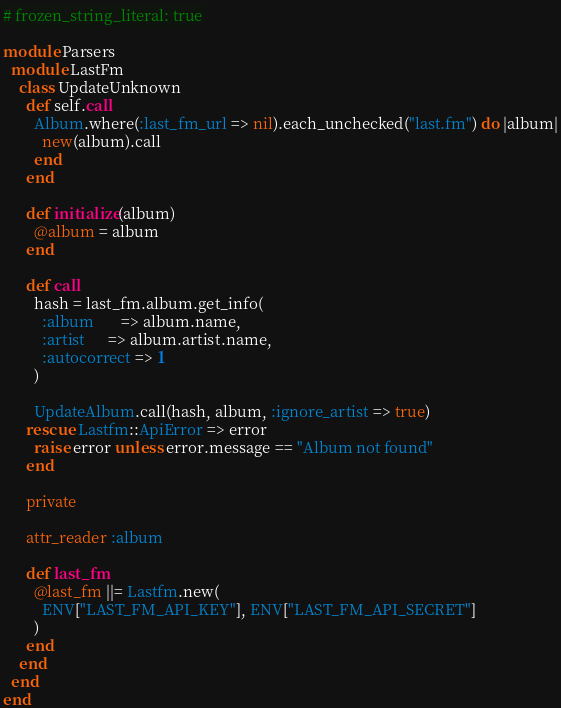Convert code to text. <code><loc_0><loc_0><loc_500><loc_500><_Ruby_># frozen_string_literal: true

module Parsers
  module LastFm
    class UpdateUnknown
      def self.call
        Album.where(:last_fm_url => nil).each_unchecked("last.fm") do |album|
          new(album).call
        end
      end

      def initialize(album)
        @album = album
      end

      def call
        hash = last_fm.album.get_info(
          :album       => album.name,
          :artist      => album.artist.name,
          :autocorrect => 1
        )

        UpdateAlbum.call(hash, album, :ignore_artist => true)
      rescue Lastfm::ApiError => error
        raise error unless error.message == "Album not found"
      end

      private

      attr_reader :album

      def last_fm
        @last_fm ||= Lastfm.new(
          ENV["LAST_FM_API_KEY"], ENV["LAST_FM_API_SECRET"]
        )
      end
    end
  end
end
</code> 